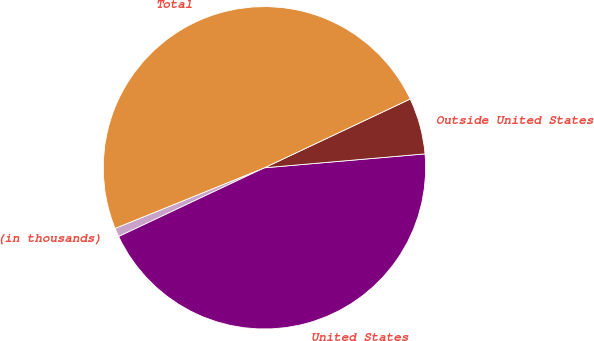Convert chart to OTSL. <chart><loc_0><loc_0><loc_500><loc_500><pie_chart><fcel>(in thousands)<fcel>United States<fcel>Outside United States<fcel>Total<nl><fcel>0.88%<fcel>44.36%<fcel>5.64%<fcel>49.12%<nl></chart> 